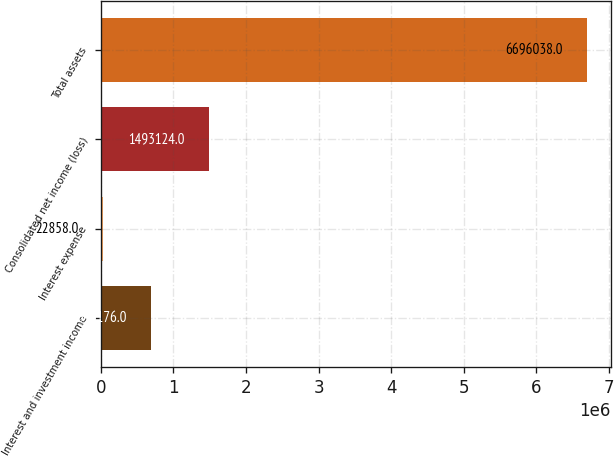Convert chart. <chart><loc_0><loc_0><loc_500><loc_500><bar_chart><fcel>Interest and investment income<fcel>Interest expense<fcel>Consolidated net income (loss)<fcel>Total assets<nl><fcel>690176<fcel>22858<fcel>1.49312e+06<fcel>6.69604e+06<nl></chart> 